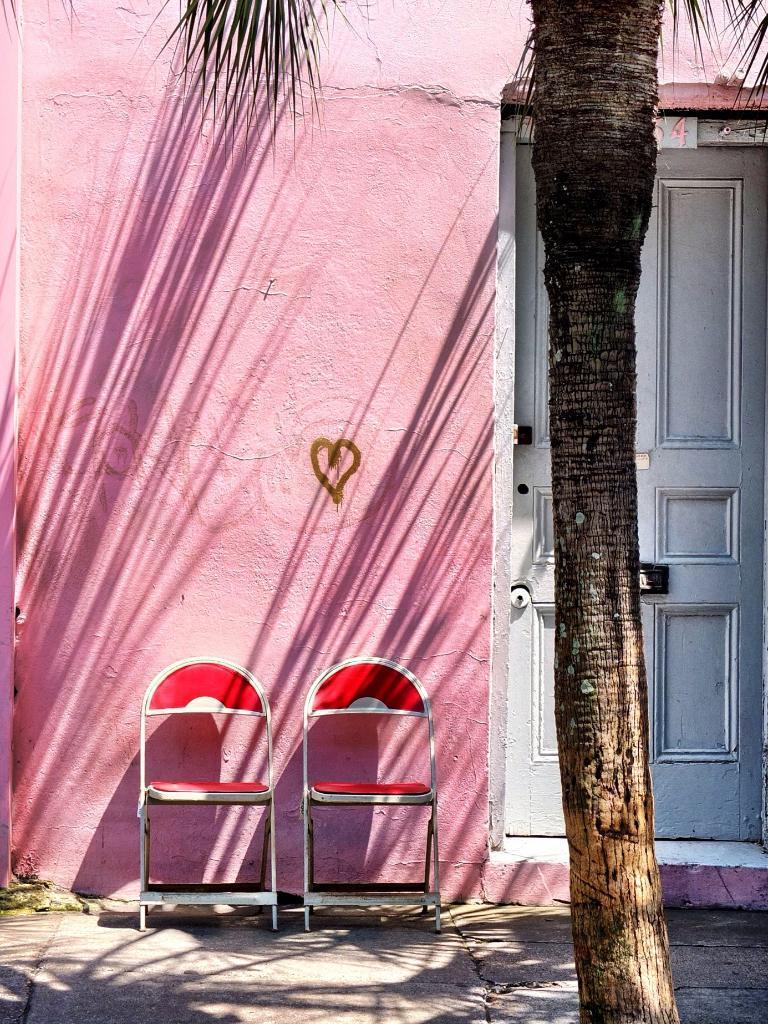Describe this image in one or two sentences. In this picture we can see chairs on the ground, here we can see a tree, wall and a door. 